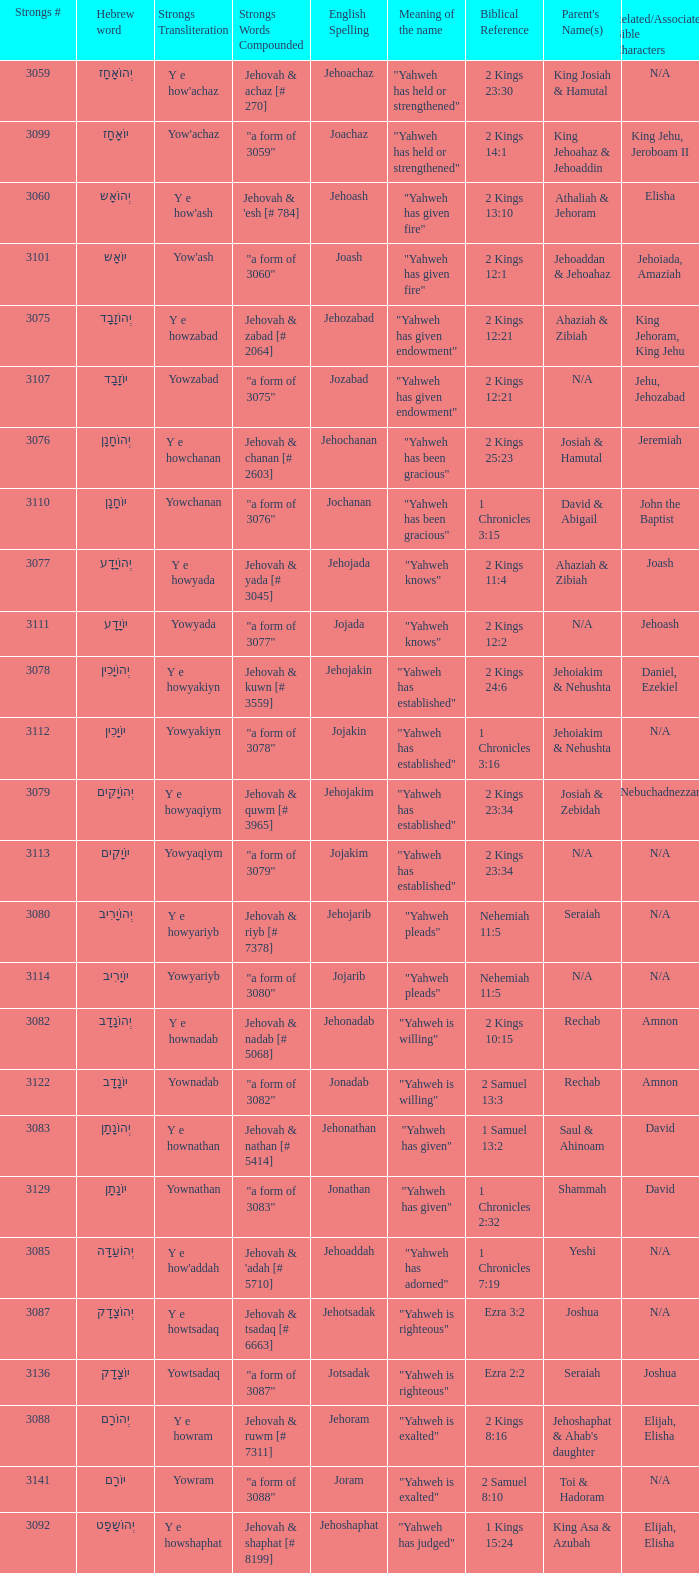What is the strongs words compounded when the english spelling is jonadab? "a form of 3082". 